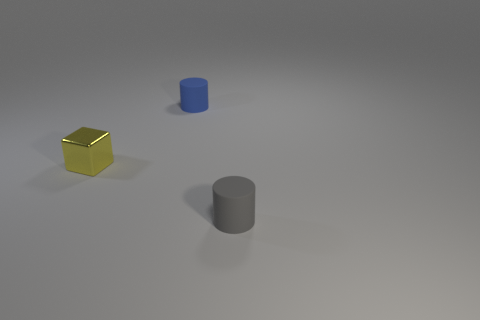Add 1 shiny objects. How many objects exist? 4 Subtract all cylinders. How many objects are left? 1 Subtract all rubber things. Subtract all small yellow spheres. How many objects are left? 1 Add 2 yellow cubes. How many yellow cubes are left? 3 Add 3 tiny shiny cylinders. How many tiny shiny cylinders exist? 3 Subtract 1 blue cylinders. How many objects are left? 2 